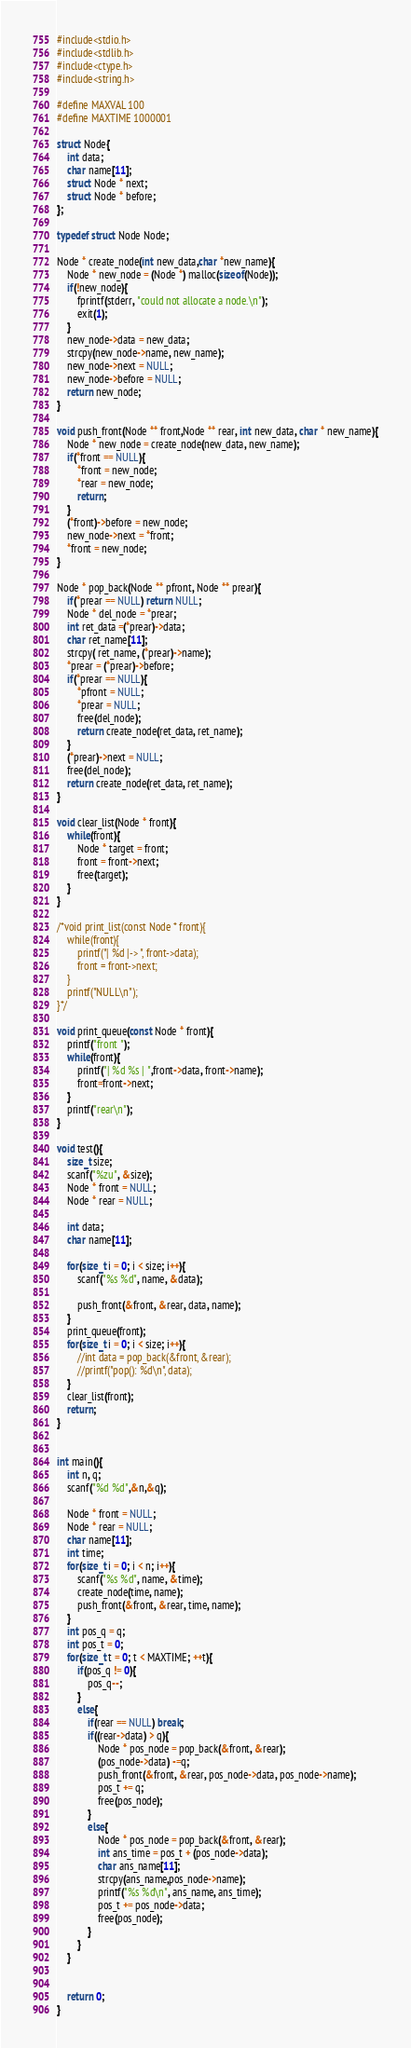Convert code to text. <code><loc_0><loc_0><loc_500><loc_500><_C_>#include<stdio.h>
#include<stdlib.h>
#include<ctype.h>
#include<string.h>

#define MAXVAL 100
#define MAXTIME 1000001

struct Node{
    int data;
    char name[11];
    struct Node * next;
    struct Node * before;
};

typedef struct Node Node;

Node * create_node(int new_data,char *new_name){
    Node * new_node = (Node *) malloc(sizeof(Node));
    if(!new_node){
        fprintf(stderr, "could not allocate a node.\n");
        exit(1);
    }
    new_node->data = new_data;
    strcpy(new_node->name, new_name);
    new_node->next = NULL;
    new_node->before = NULL;
    return new_node;
}

void push_front(Node ** front,Node ** rear, int new_data, char * new_name){
    Node * new_node = create_node(new_data, new_name);
    if(*front == NULL){
        *front = new_node;
        *rear = new_node;
        return;
    }
    (*front)->before = new_node;
    new_node->next = *front;
    *front = new_node;
}

Node * pop_back(Node ** pfront, Node ** prear){
    if(*prear == NULL) return NULL;
    Node * del_node = *prear;
    int ret_data =(*prear)->data;
    char ret_name[11];
    strcpy( ret_name, (*prear)->name);
    *prear = (*prear)->before;
    if(*prear == NULL){
        *pfront = NULL;
        *prear = NULL;
        free(del_node);
        return create_node(ret_data, ret_name);
    }
    (*prear)->next = NULL;
    free(del_node);
    return create_node(ret_data, ret_name);
}

void clear_list(Node * front){
    while(front){
        Node * target = front;
        front = front->next;
        free(target);
    }
}

/*void print_list(const Node * front){
    while(front){
        printf("| %d |-> ", front->data);
        front = front->next;
    }
    printf("NULL\n");
}*/

void print_queue(const Node * front){
    printf("front ");
    while(front){
        printf("| %d %s | ",front->data, front->name);
        front=front->next;
    }
    printf("rear\n");
}

void test(){
    size_t size;
    scanf("%zu", &size);
    Node * front = NULL;
    Node * rear = NULL;

    int data;
    char name[11];
    
    for(size_t i = 0; i < size; i++){
        scanf("%s %d", name, &data);

        push_front(&front, &rear, data, name);
    }
    print_queue(front);
    for(size_t i = 0; i < size; i++){
        //int data = pop_back(&front, &rear);
        //printf("pop(): %d\n", data);
    }
    clear_list(front);
    return;
}


int main(){
    int n, q;
    scanf("%d %d",&n,&q);

    Node * front = NULL;
    Node * rear = NULL;
    char name[11];
    int time;
    for(size_t i = 0; i < n; i++){
        scanf("%s %d", name, &time);
        create_node(time, name);
        push_front(&front, &rear, time, name);
    }
    int pos_q = q;
    int pos_t = 0;
    for(size_t t = 0; t < MAXTIME; ++t){
        if(pos_q != 0){
            pos_q--;
        }
        else{
            if(rear == NULL) break;
            if((rear->data) > q){
                Node * pos_node = pop_back(&front, &rear);
                (pos_node->data) -=q;
                push_front(&front, &rear, pos_node->data, pos_node->name);
                pos_t += q;
                free(pos_node);
            }
            else{
                Node * pos_node = pop_back(&front, &rear);
                int ans_time = pos_t + (pos_node->data);
                char ans_name[11];
                strcpy(ans_name,pos_node->name);
                printf("%s %d\n", ans_name, ans_time);
                pos_t += pos_node->data;
                free(pos_node);
            }
        }
    }


    return 0;
}
</code> 